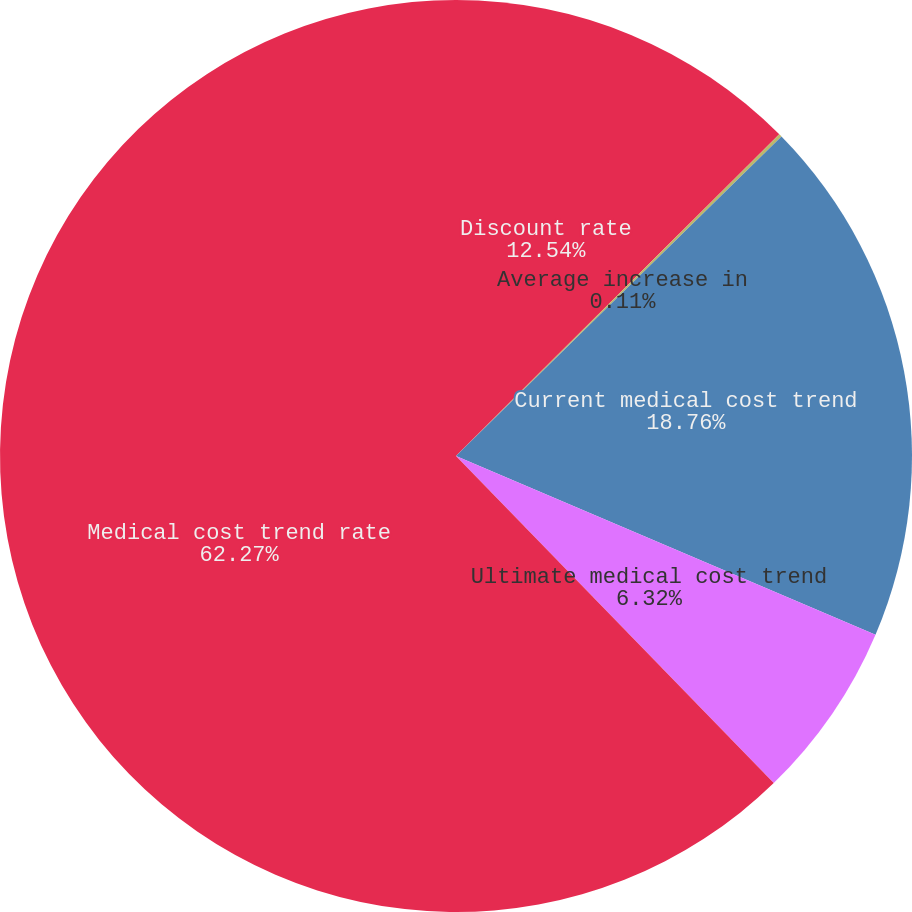Convert chart to OTSL. <chart><loc_0><loc_0><loc_500><loc_500><pie_chart><fcel>Discount rate<fcel>Average increase in<fcel>Current medical cost trend<fcel>Ultimate medical cost trend<fcel>Medical cost trend rate<nl><fcel>12.54%<fcel>0.11%<fcel>18.76%<fcel>6.32%<fcel>62.27%<nl></chart> 